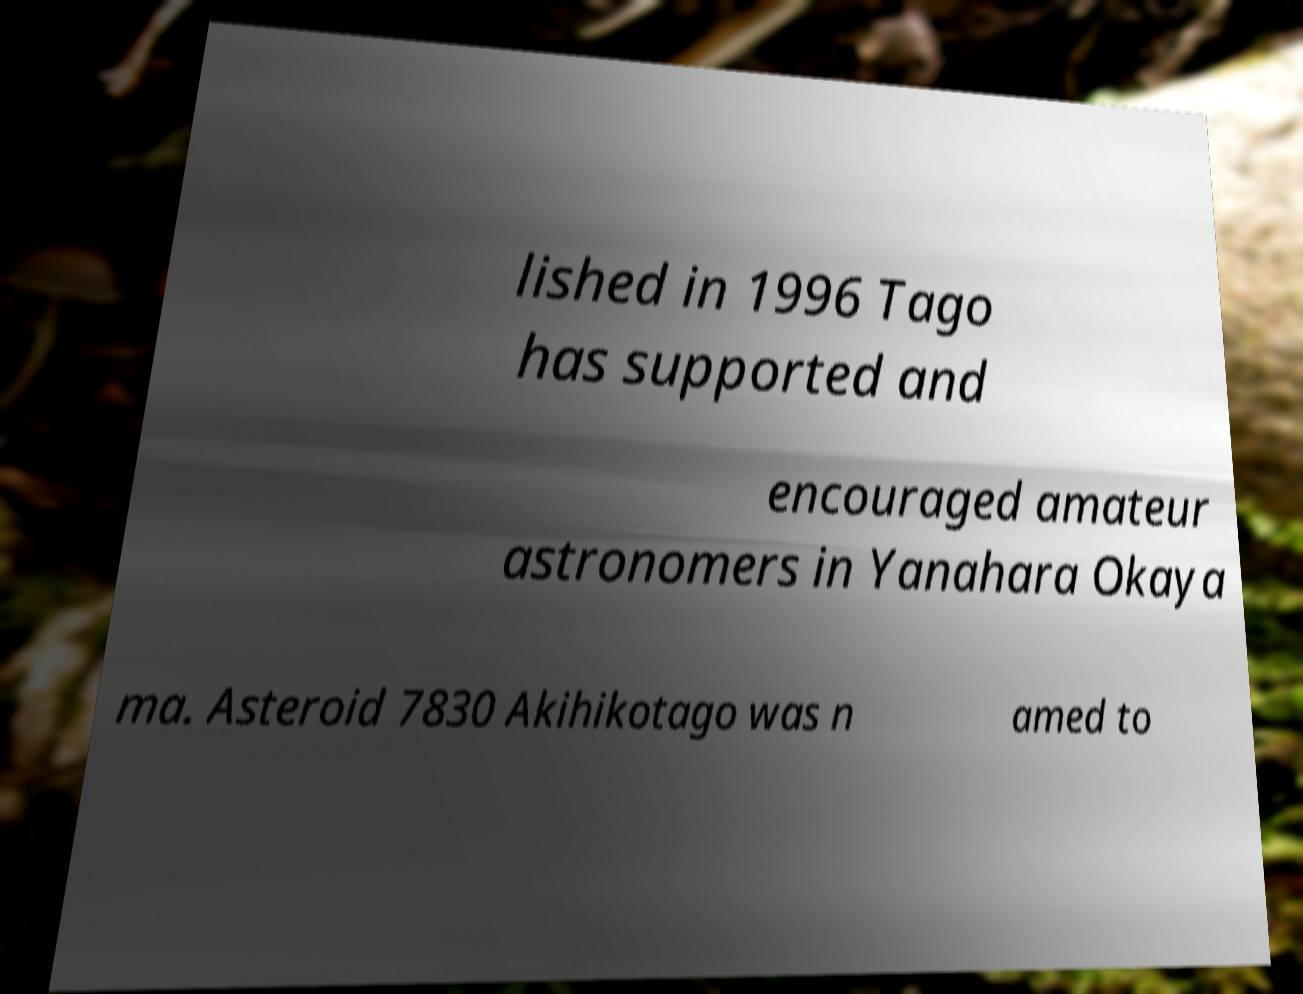For documentation purposes, I need the text within this image transcribed. Could you provide that? lished in 1996 Tago has supported and encouraged amateur astronomers in Yanahara Okaya ma. Asteroid 7830 Akihikotago was n amed to 